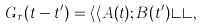<formula> <loc_0><loc_0><loc_500><loc_500>G _ { r } ( t - t ^ { \prime } ) = \langle \langle A ( t ) ; B ( t ^ { \prime } ) \rangle \rangle ,</formula> 